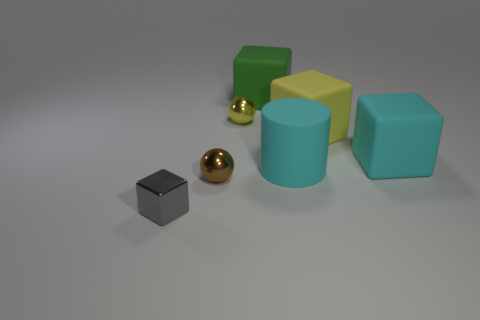How does the lighting in this image affect the perception of the objects? The soft overhead lighting in the image creates gentle shadows and highlights the texture of the objects, providing a calm and neutral atmosphere that allows each object's color and form to stand out without harsh contrasts. 